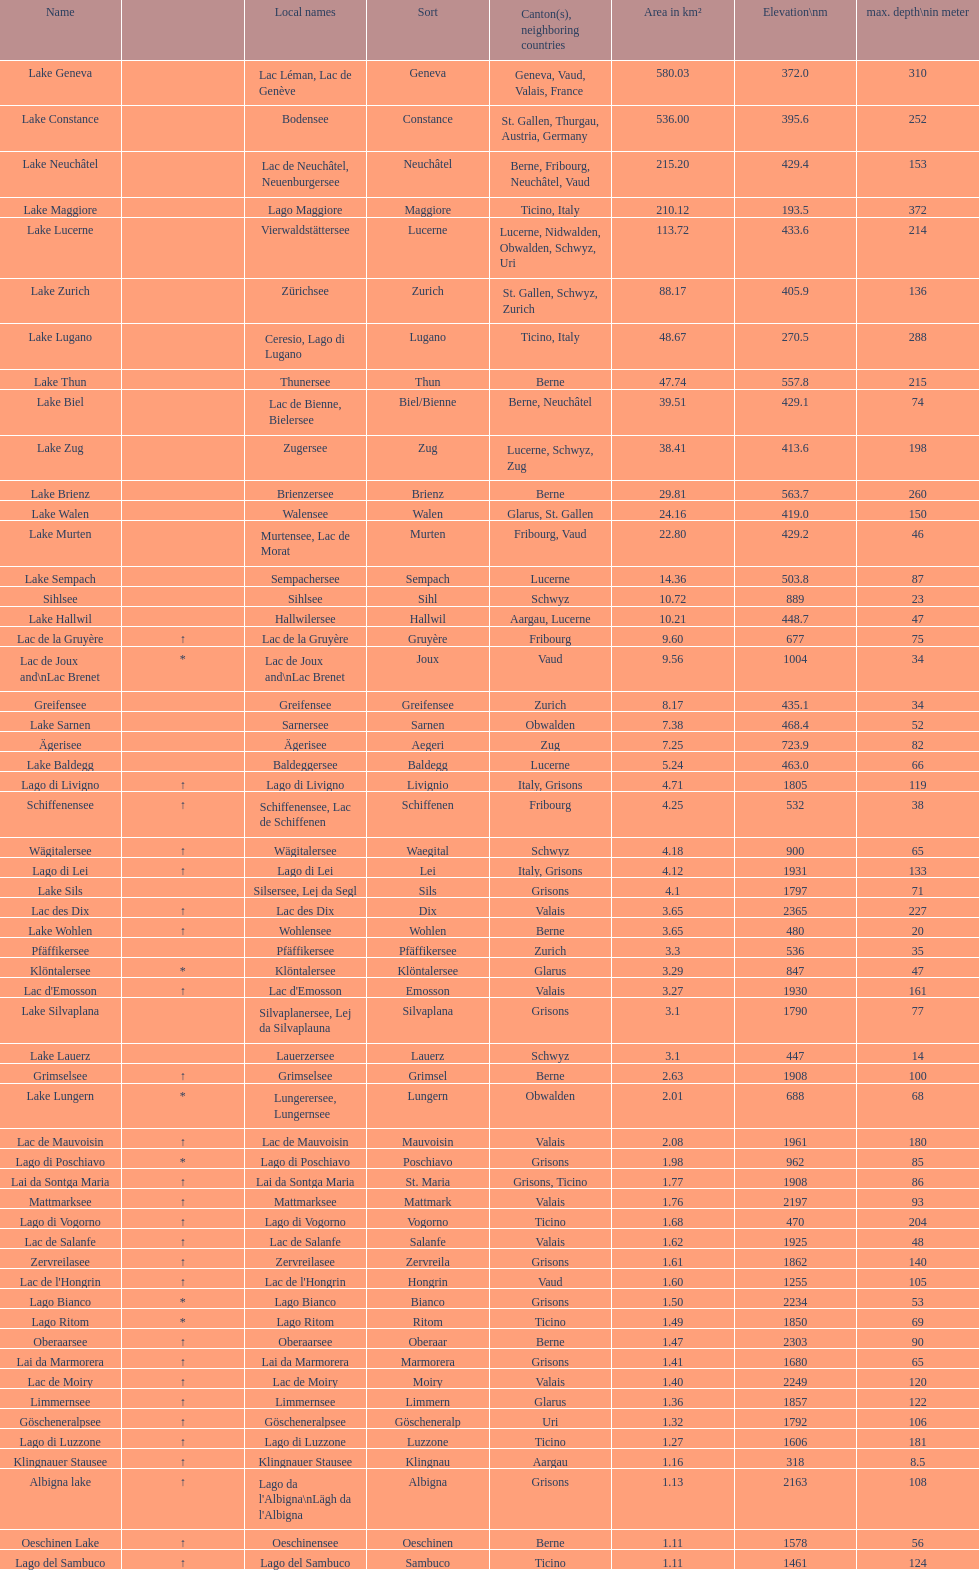Identify the sole lake that reaches a depth of 372 meters at its deepest point. Lake Maggiore. 